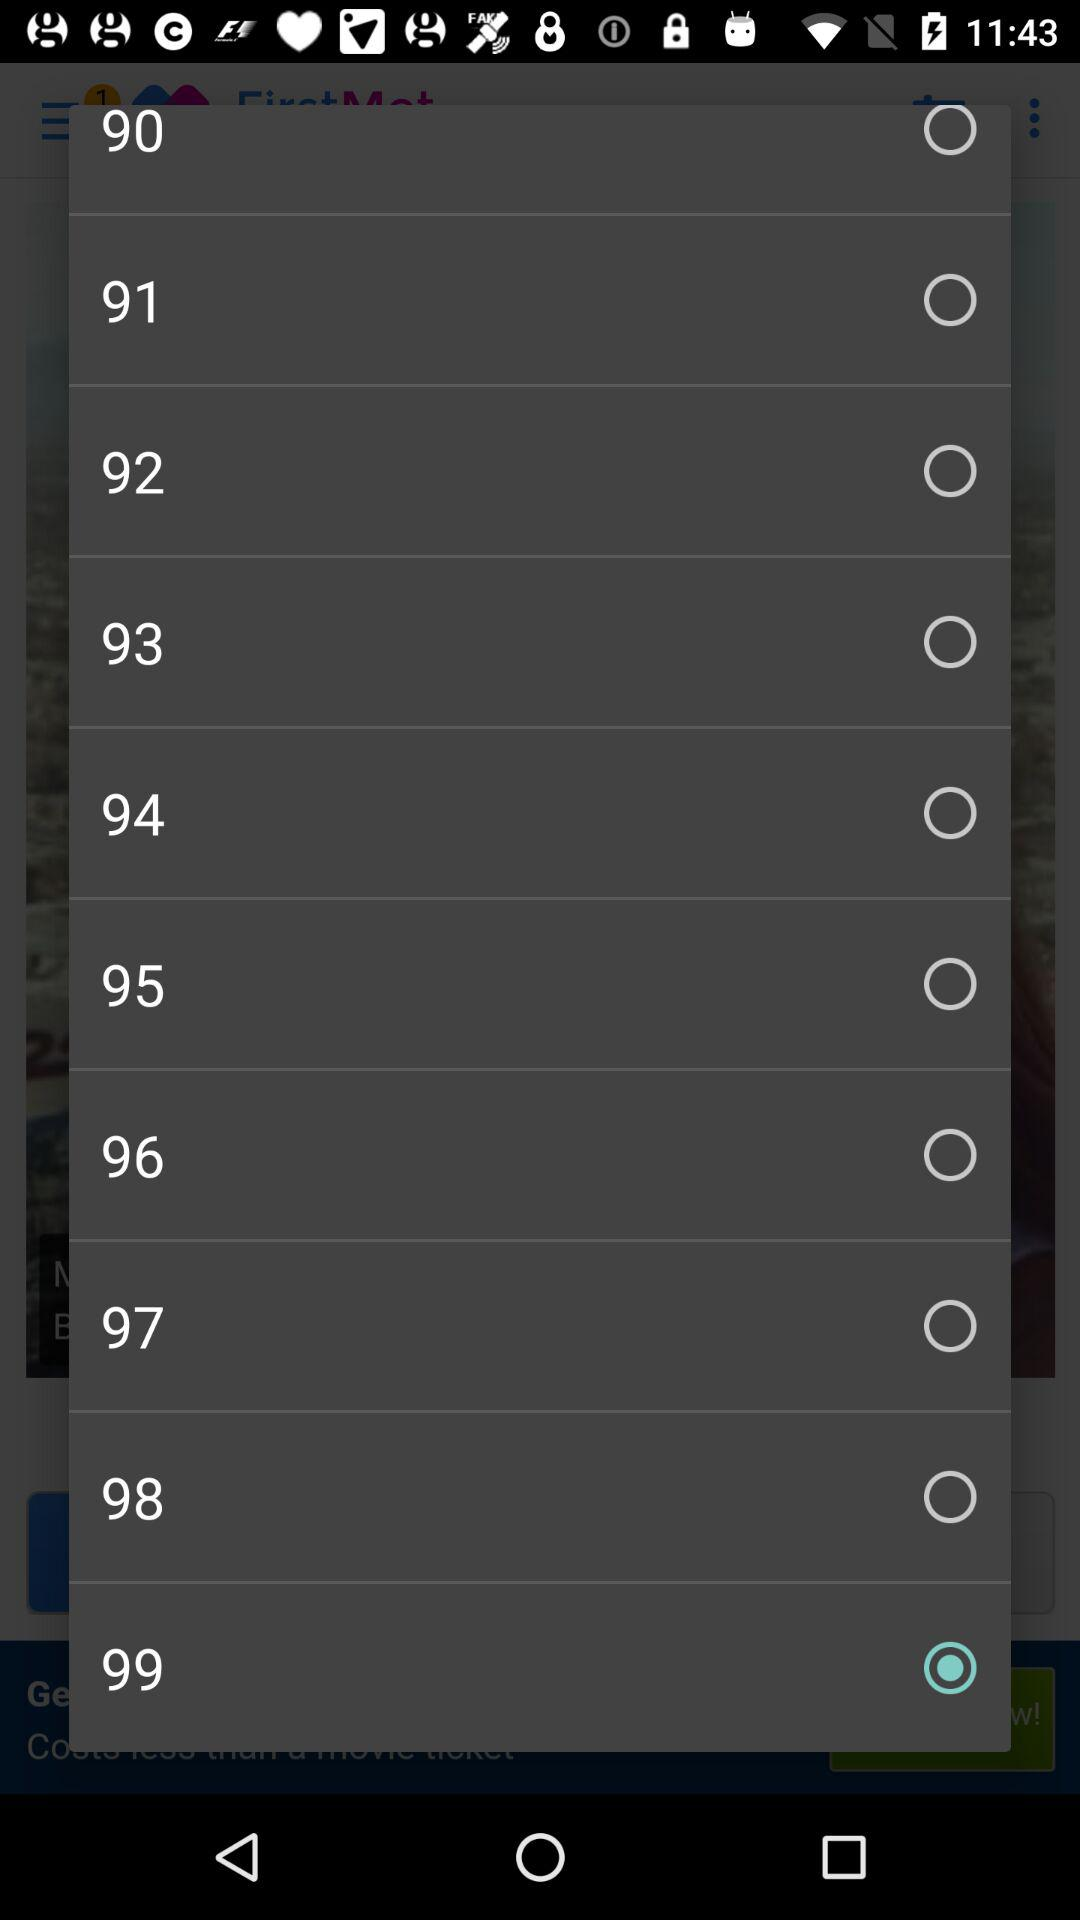Which option has been selected? The selected option is "99". 